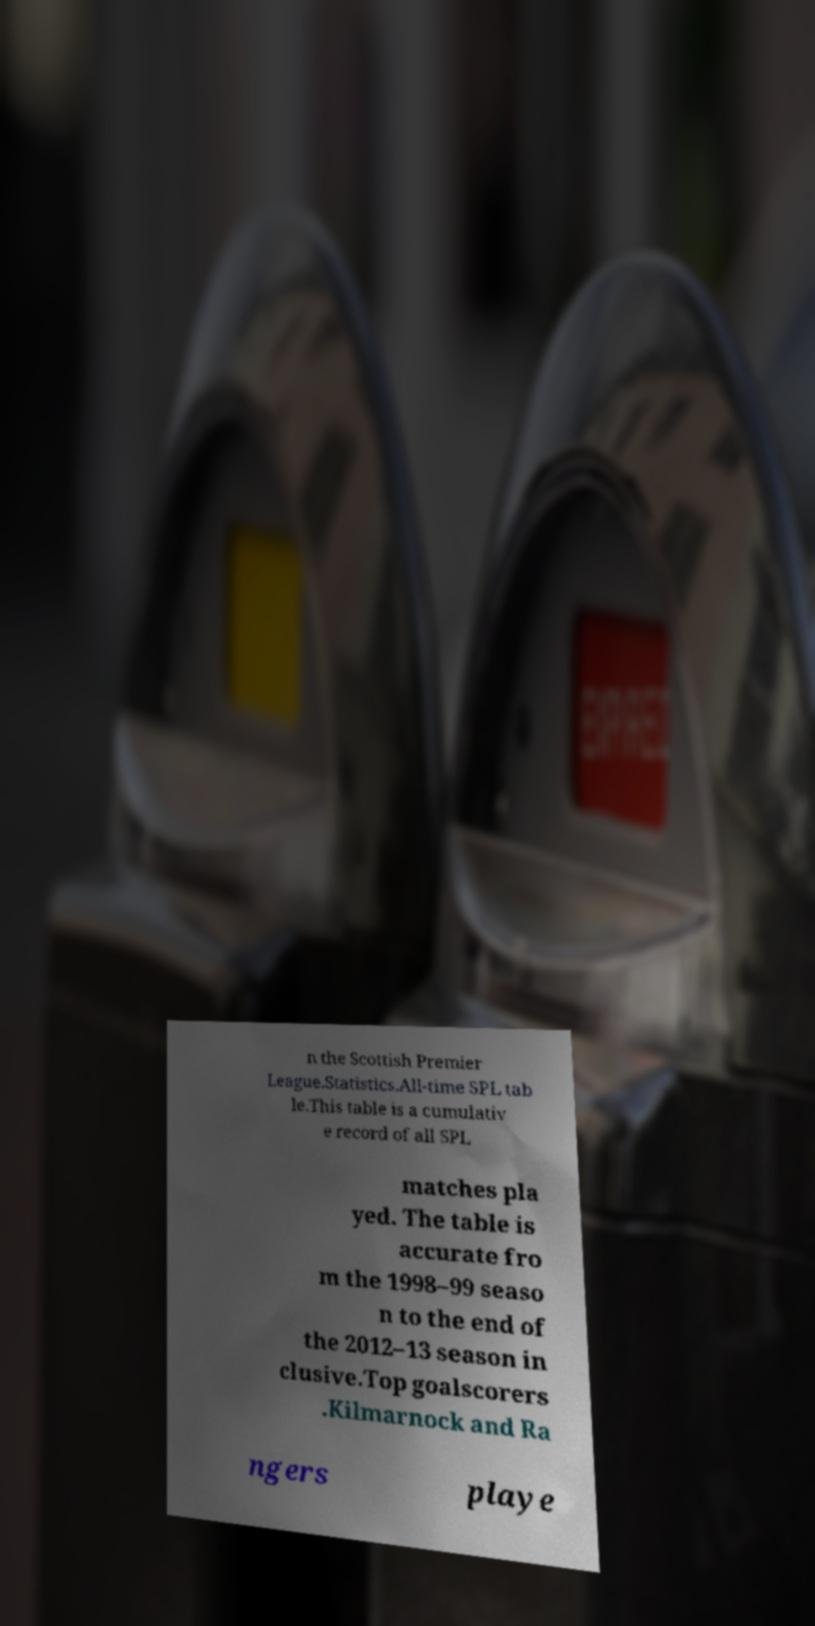Can you accurately transcribe the text from the provided image for me? n the Scottish Premier League.Statistics.All-time SPL tab le.This table is a cumulativ e record of all SPL matches pla yed. The table is accurate fro m the 1998–99 seaso n to the end of the 2012–13 season in clusive.Top goalscorers .Kilmarnock and Ra ngers playe 